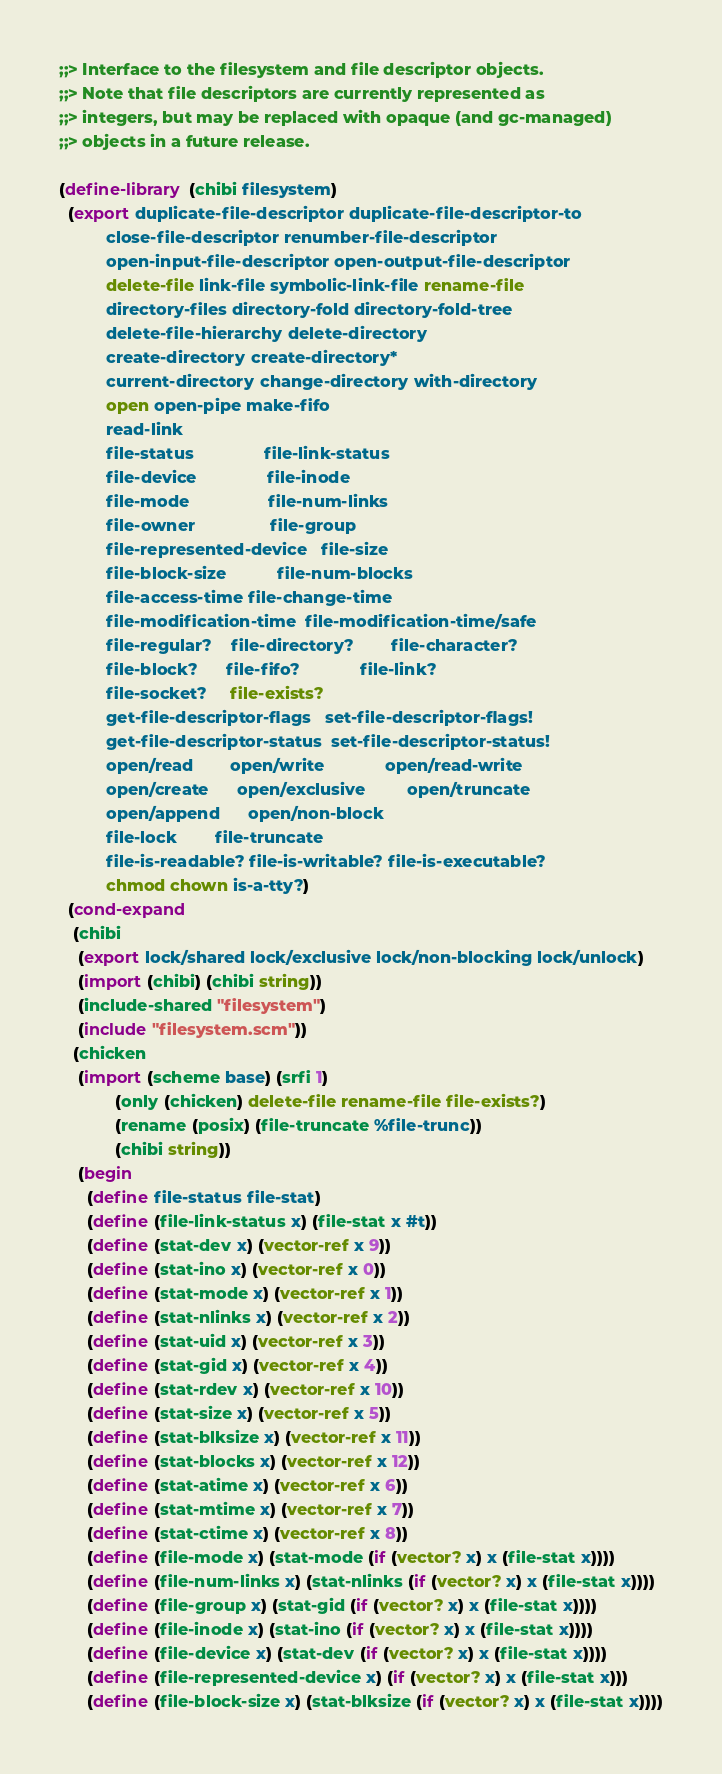<code> <loc_0><loc_0><loc_500><loc_500><_Scheme_>
;;> Interface to the filesystem and file descriptor objects.
;;> Note that file descriptors are currently represented as
;;> integers, but may be replaced with opaque (and gc-managed)
;;> objects in a future release.

(define-library (chibi filesystem)
  (export duplicate-file-descriptor duplicate-file-descriptor-to
          close-file-descriptor renumber-file-descriptor
          open-input-file-descriptor open-output-file-descriptor
          delete-file link-file symbolic-link-file rename-file
          directory-files directory-fold directory-fold-tree
          delete-file-hierarchy delete-directory
          create-directory create-directory*
          current-directory change-directory with-directory
          open open-pipe make-fifo
          read-link
          file-status               file-link-status
          file-device               file-inode
          file-mode                 file-num-links
          file-owner                file-group
          file-represented-device   file-size
          file-block-size           file-num-blocks
          file-access-time file-change-time
          file-modification-time  file-modification-time/safe
          file-regular?    file-directory?        file-character?
          file-block?      file-fifo?             file-link?
          file-socket?     file-exists?
          get-file-descriptor-flags   set-file-descriptor-flags!
          get-file-descriptor-status  set-file-descriptor-status!
          open/read        open/write             open/read-write
          open/create      open/exclusive         open/truncate
          open/append      open/non-block
          file-lock        file-truncate
          file-is-readable? file-is-writable? file-is-executable?
          chmod chown is-a-tty?)
  (cond-expand
   (chibi
    (export lock/shared lock/exclusive lock/non-blocking lock/unlock)
    (import (chibi) (chibi string))
    (include-shared "filesystem")
    (include "filesystem.scm"))
   (chicken
    (import (scheme base) (srfi 1)
            (only (chicken) delete-file rename-file file-exists?)
            (rename (posix) (file-truncate %file-trunc))
            (chibi string))
    (begin
      (define file-status file-stat)
      (define (file-link-status x) (file-stat x #t))
      (define (stat-dev x) (vector-ref x 9))
      (define (stat-ino x) (vector-ref x 0))
      (define (stat-mode x) (vector-ref x 1))
      (define (stat-nlinks x) (vector-ref x 2))
      (define (stat-uid x) (vector-ref x 3))
      (define (stat-gid x) (vector-ref x 4))
      (define (stat-rdev x) (vector-ref x 10))
      (define (stat-size x) (vector-ref x 5))
      (define (stat-blksize x) (vector-ref x 11))
      (define (stat-blocks x) (vector-ref x 12))
      (define (stat-atime x) (vector-ref x 6))
      (define (stat-mtime x) (vector-ref x 7))
      (define (stat-ctime x) (vector-ref x 8))
      (define (file-mode x) (stat-mode (if (vector? x) x (file-stat x))))
      (define (file-num-links x) (stat-nlinks (if (vector? x) x (file-stat x))))
      (define (file-group x) (stat-gid (if (vector? x) x (file-stat x))))
      (define (file-inode x) (stat-ino (if (vector? x) x (file-stat x))))
      (define (file-device x) (stat-dev (if (vector? x) x (file-stat x))))
      (define (file-represented-device x) (if (vector? x) x (file-stat x)))
      (define (file-block-size x) (stat-blksize (if (vector? x) x (file-stat x))))</code> 